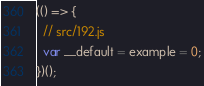Convert code to text. <code><loc_0><loc_0><loc_500><loc_500><_JavaScript_>(() => {
  // src/192.js
  var __default = example = 0;
})();
</code> 